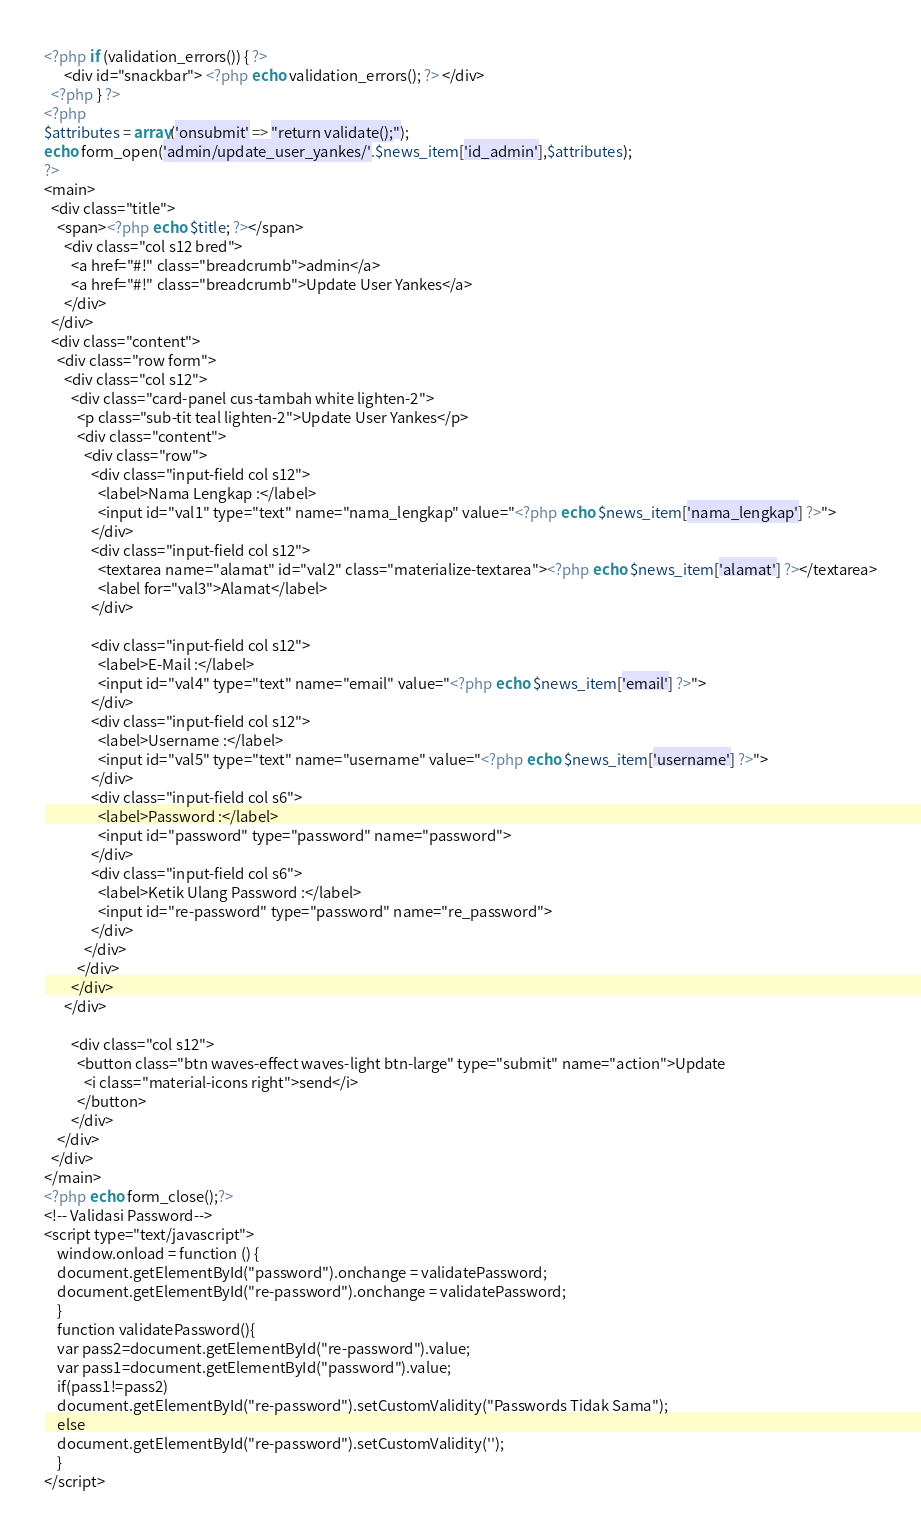Convert code to text. <code><loc_0><loc_0><loc_500><loc_500><_PHP_><?php if (validation_errors()) { ?>
      <div id="snackbar"> <?php echo validation_errors(); ?> </div>
  <?php } ?>
<?php
$attributes = array('onsubmit' => "return validate();");
echo form_open('admin/update_user_yankes/'.$news_item['id_admin'],$attributes);
?>
<main>
  <div class="title">
    <span><?php echo $title; ?></span>
      <div class="col s12 bred">
        <a href="#!" class="breadcrumb">admin</a>
        <a href="#!" class="breadcrumb">Update User Yankes</a>
      </div>
  </div>
  <div class="content">
    <div class="row form">
      <div class="col s12">
        <div class="card-panel cus-tambah white lighten-2">
          <p class="sub-tit teal lighten-2">Update User Yankes</p>
          <div class="content">
            <div class="row">
              <div class="input-field col s12">
                <label>Nama Lengkap :</label>
                <input id="val1" type="text" name="nama_lengkap" value="<?php echo $news_item['nama_lengkap'] ?>">
              </div>
              <div class="input-field col s12">
                <textarea name="alamat" id="val2" class="materialize-textarea"><?php echo $news_item['alamat'] ?></textarea>
                <label for="val3">Alamat</label>
              </div>

              <div class="input-field col s12">
                <label>E-Mail :</label>
                <input id="val4" type="text" name="email" value="<?php echo $news_item['email'] ?>">
              </div>
              <div class="input-field col s12">
                <label>Username :</label>
                <input id="val5" type="text" name="username" value="<?php echo $news_item['username'] ?>">
              </div>
              <div class="input-field col s6">
                <label>Password :</label>
                <input id="password" type="password" name="password">
              </div>
              <div class="input-field col s6">
                <label>Ketik Ulang Password :</label>
                <input id="re-password" type="password" name="re_password">
              </div>
            </div>
          </div>
        </div>
      </div>

        <div class="col s12">
          <button class="btn waves-effect waves-light btn-large" type="submit" name="action">Update
            <i class="material-icons right">send</i>
          </button>
        </div>
    </div>
  </div>
</main>
<?php echo form_close();?>
<!-- Validasi Password-->
<script type="text/javascript">
    window.onload = function () {
    document.getElementById("password").onchange = validatePassword;
    document.getElementById("re-password").onchange = validatePassword;
    }
    function validatePassword(){
    var pass2=document.getElementById("re-password").value;
    var pass1=document.getElementById("password").value;
    if(pass1!=pass2)
    document.getElementById("re-password").setCustomValidity("Passwords Tidak Sama");
    else
    document.getElementById("re-password").setCustomValidity('');
	}
</script>
</code> 